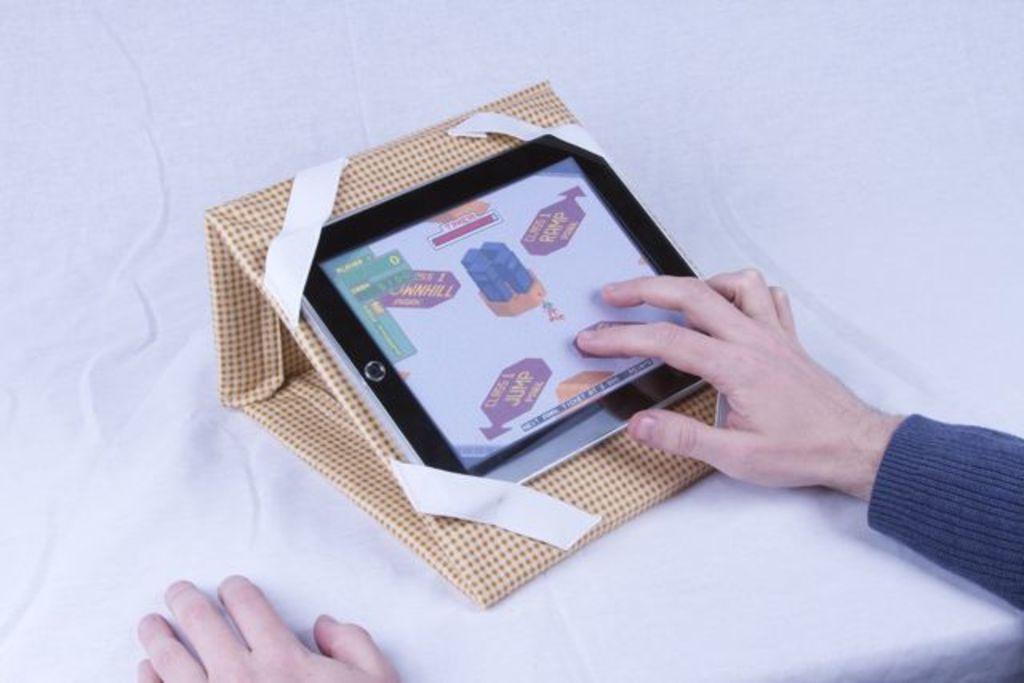How would you summarize this image in a sentence or two? In the image there is an object kept on a white surface and there are two hands of a person visible in the image, the first hand is placed on the object. 